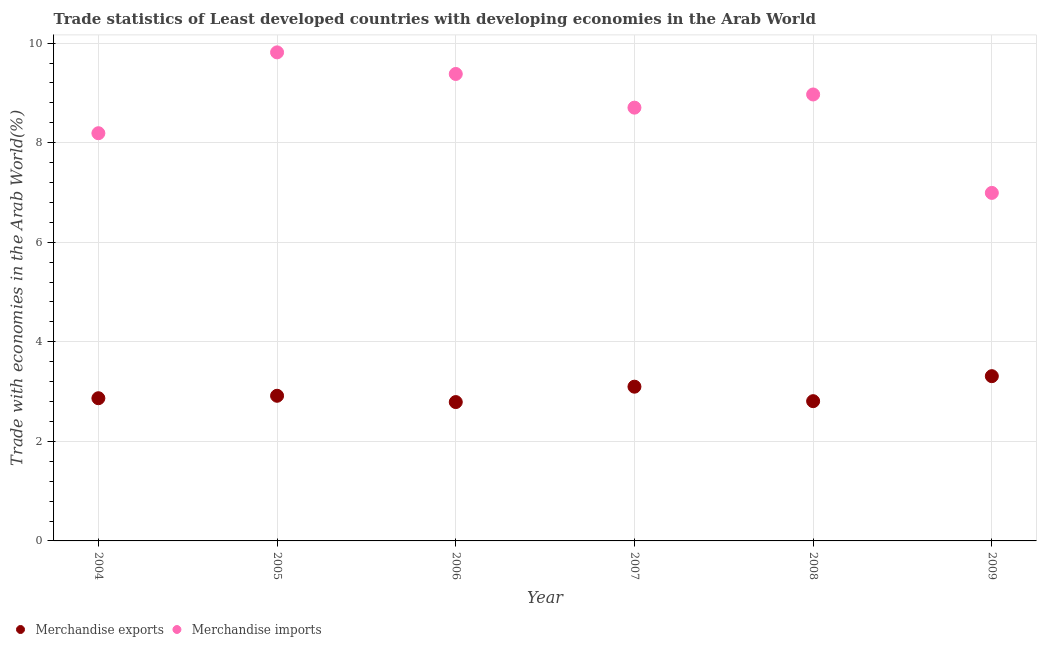How many different coloured dotlines are there?
Provide a succinct answer. 2. Is the number of dotlines equal to the number of legend labels?
Your answer should be very brief. Yes. What is the merchandise imports in 2009?
Make the answer very short. 6.99. Across all years, what is the maximum merchandise exports?
Offer a terse response. 3.31. Across all years, what is the minimum merchandise imports?
Offer a very short reply. 6.99. In which year was the merchandise exports maximum?
Provide a short and direct response. 2009. In which year was the merchandise imports minimum?
Your answer should be compact. 2009. What is the total merchandise imports in the graph?
Your answer should be compact. 52.05. What is the difference between the merchandise exports in 2004 and that in 2008?
Offer a very short reply. 0.06. What is the difference between the merchandise imports in 2005 and the merchandise exports in 2004?
Your response must be concise. 6.95. What is the average merchandise imports per year?
Your answer should be compact. 8.68. In the year 2004, what is the difference between the merchandise imports and merchandise exports?
Provide a succinct answer. 5.32. In how many years, is the merchandise exports greater than 6 %?
Ensure brevity in your answer.  0. What is the ratio of the merchandise imports in 2004 to that in 2006?
Provide a short and direct response. 0.87. Is the difference between the merchandise exports in 2007 and 2009 greater than the difference between the merchandise imports in 2007 and 2009?
Your answer should be very brief. No. What is the difference between the highest and the second highest merchandise exports?
Provide a succinct answer. 0.21. What is the difference between the highest and the lowest merchandise exports?
Provide a short and direct response. 0.52. Is the sum of the merchandise exports in 2007 and 2008 greater than the maximum merchandise imports across all years?
Provide a succinct answer. No. Does the merchandise imports monotonically increase over the years?
Give a very brief answer. No. Is the merchandise exports strictly greater than the merchandise imports over the years?
Your response must be concise. No. Is the merchandise imports strictly less than the merchandise exports over the years?
Your response must be concise. No. How many dotlines are there?
Offer a terse response. 2. Does the graph contain any zero values?
Provide a short and direct response. No. How are the legend labels stacked?
Offer a terse response. Horizontal. What is the title of the graph?
Your response must be concise. Trade statistics of Least developed countries with developing economies in the Arab World. Does "Merchandise imports" appear as one of the legend labels in the graph?
Offer a terse response. Yes. What is the label or title of the Y-axis?
Offer a very short reply. Trade with economies in the Arab World(%). What is the Trade with economies in the Arab World(%) in Merchandise exports in 2004?
Provide a succinct answer. 2.87. What is the Trade with economies in the Arab World(%) in Merchandise imports in 2004?
Ensure brevity in your answer.  8.19. What is the Trade with economies in the Arab World(%) of Merchandise exports in 2005?
Offer a very short reply. 2.92. What is the Trade with economies in the Arab World(%) of Merchandise imports in 2005?
Give a very brief answer. 9.81. What is the Trade with economies in the Arab World(%) in Merchandise exports in 2006?
Provide a short and direct response. 2.79. What is the Trade with economies in the Arab World(%) of Merchandise imports in 2006?
Ensure brevity in your answer.  9.38. What is the Trade with economies in the Arab World(%) of Merchandise exports in 2007?
Offer a very short reply. 3.1. What is the Trade with economies in the Arab World(%) in Merchandise imports in 2007?
Keep it short and to the point. 8.7. What is the Trade with economies in the Arab World(%) in Merchandise exports in 2008?
Offer a terse response. 2.81. What is the Trade with economies in the Arab World(%) in Merchandise imports in 2008?
Ensure brevity in your answer.  8.97. What is the Trade with economies in the Arab World(%) of Merchandise exports in 2009?
Provide a succinct answer. 3.31. What is the Trade with economies in the Arab World(%) in Merchandise imports in 2009?
Keep it short and to the point. 6.99. Across all years, what is the maximum Trade with economies in the Arab World(%) of Merchandise exports?
Give a very brief answer. 3.31. Across all years, what is the maximum Trade with economies in the Arab World(%) in Merchandise imports?
Your response must be concise. 9.81. Across all years, what is the minimum Trade with economies in the Arab World(%) in Merchandise exports?
Make the answer very short. 2.79. Across all years, what is the minimum Trade with economies in the Arab World(%) in Merchandise imports?
Your answer should be compact. 6.99. What is the total Trade with economies in the Arab World(%) of Merchandise exports in the graph?
Keep it short and to the point. 17.79. What is the total Trade with economies in the Arab World(%) in Merchandise imports in the graph?
Offer a very short reply. 52.05. What is the difference between the Trade with economies in the Arab World(%) in Merchandise exports in 2004 and that in 2005?
Your answer should be very brief. -0.05. What is the difference between the Trade with economies in the Arab World(%) in Merchandise imports in 2004 and that in 2005?
Offer a terse response. -1.62. What is the difference between the Trade with economies in the Arab World(%) in Merchandise exports in 2004 and that in 2006?
Your answer should be compact. 0.08. What is the difference between the Trade with economies in the Arab World(%) in Merchandise imports in 2004 and that in 2006?
Give a very brief answer. -1.19. What is the difference between the Trade with economies in the Arab World(%) in Merchandise exports in 2004 and that in 2007?
Make the answer very short. -0.23. What is the difference between the Trade with economies in the Arab World(%) in Merchandise imports in 2004 and that in 2007?
Your response must be concise. -0.51. What is the difference between the Trade with economies in the Arab World(%) of Merchandise exports in 2004 and that in 2008?
Offer a terse response. 0.06. What is the difference between the Trade with economies in the Arab World(%) in Merchandise imports in 2004 and that in 2008?
Make the answer very short. -0.78. What is the difference between the Trade with economies in the Arab World(%) in Merchandise exports in 2004 and that in 2009?
Your answer should be very brief. -0.44. What is the difference between the Trade with economies in the Arab World(%) in Merchandise imports in 2004 and that in 2009?
Offer a very short reply. 1.2. What is the difference between the Trade with economies in the Arab World(%) of Merchandise exports in 2005 and that in 2006?
Your answer should be compact. 0.13. What is the difference between the Trade with economies in the Arab World(%) in Merchandise imports in 2005 and that in 2006?
Provide a succinct answer. 0.43. What is the difference between the Trade with economies in the Arab World(%) in Merchandise exports in 2005 and that in 2007?
Provide a short and direct response. -0.18. What is the difference between the Trade with economies in the Arab World(%) of Merchandise imports in 2005 and that in 2007?
Offer a very short reply. 1.11. What is the difference between the Trade with economies in the Arab World(%) in Merchandise exports in 2005 and that in 2008?
Your answer should be compact. 0.11. What is the difference between the Trade with economies in the Arab World(%) in Merchandise imports in 2005 and that in 2008?
Your answer should be compact. 0.85. What is the difference between the Trade with economies in the Arab World(%) of Merchandise exports in 2005 and that in 2009?
Ensure brevity in your answer.  -0.39. What is the difference between the Trade with economies in the Arab World(%) of Merchandise imports in 2005 and that in 2009?
Keep it short and to the point. 2.82. What is the difference between the Trade with economies in the Arab World(%) in Merchandise exports in 2006 and that in 2007?
Ensure brevity in your answer.  -0.31. What is the difference between the Trade with economies in the Arab World(%) in Merchandise imports in 2006 and that in 2007?
Your response must be concise. 0.68. What is the difference between the Trade with economies in the Arab World(%) in Merchandise exports in 2006 and that in 2008?
Offer a terse response. -0.02. What is the difference between the Trade with economies in the Arab World(%) of Merchandise imports in 2006 and that in 2008?
Your answer should be very brief. 0.41. What is the difference between the Trade with economies in the Arab World(%) of Merchandise exports in 2006 and that in 2009?
Provide a short and direct response. -0.52. What is the difference between the Trade with economies in the Arab World(%) of Merchandise imports in 2006 and that in 2009?
Your answer should be compact. 2.39. What is the difference between the Trade with economies in the Arab World(%) of Merchandise exports in 2007 and that in 2008?
Your response must be concise. 0.29. What is the difference between the Trade with economies in the Arab World(%) in Merchandise imports in 2007 and that in 2008?
Offer a very short reply. -0.26. What is the difference between the Trade with economies in the Arab World(%) of Merchandise exports in 2007 and that in 2009?
Your answer should be compact. -0.21. What is the difference between the Trade with economies in the Arab World(%) of Merchandise imports in 2007 and that in 2009?
Offer a terse response. 1.71. What is the difference between the Trade with economies in the Arab World(%) of Merchandise exports in 2008 and that in 2009?
Ensure brevity in your answer.  -0.5. What is the difference between the Trade with economies in the Arab World(%) of Merchandise imports in 2008 and that in 2009?
Your response must be concise. 1.98. What is the difference between the Trade with economies in the Arab World(%) in Merchandise exports in 2004 and the Trade with economies in the Arab World(%) in Merchandise imports in 2005?
Ensure brevity in your answer.  -6.95. What is the difference between the Trade with economies in the Arab World(%) in Merchandise exports in 2004 and the Trade with economies in the Arab World(%) in Merchandise imports in 2006?
Your answer should be very brief. -6.51. What is the difference between the Trade with economies in the Arab World(%) in Merchandise exports in 2004 and the Trade with economies in the Arab World(%) in Merchandise imports in 2007?
Your answer should be compact. -5.84. What is the difference between the Trade with economies in the Arab World(%) of Merchandise exports in 2004 and the Trade with economies in the Arab World(%) of Merchandise imports in 2008?
Offer a very short reply. -6.1. What is the difference between the Trade with economies in the Arab World(%) of Merchandise exports in 2004 and the Trade with economies in the Arab World(%) of Merchandise imports in 2009?
Make the answer very short. -4.12. What is the difference between the Trade with economies in the Arab World(%) in Merchandise exports in 2005 and the Trade with economies in the Arab World(%) in Merchandise imports in 2006?
Provide a short and direct response. -6.46. What is the difference between the Trade with economies in the Arab World(%) of Merchandise exports in 2005 and the Trade with economies in the Arab World(%) of Merchandise imports in 2007?
Your answer should be very brief. -5.79. What is the difference between the Trade with economies in the Arab World(%) in Merchandise exports in 2005 and the Trade with economies in the Arab World(%) in Merchandise imports in 2008?
Make the answer very short. -6.05. What is the difference between the Trade with economies in the Arab World(%) of Merchandise exports in 2005 and the Trade with economies in the Arab World(%) of Merchandise imports in 2009?
Make the answer very short. -4.08. What is the difference between the Trade with economies in the Arab World(%) in Merchandise exports in 2006 and the Trade with economies in the Arab World(%) in Merchandise imports in 2007?
Provide a short and direct response. -5.91. What is the difference between the Trade with economies in the Arab World(%) in Merchandise exports in 2006 and the Trade with economies in the Arab World(%) in Merchandise imports in 2008?
Offer a terse response. -6.18. What is the difference between the Trade with economies in the Arab World(%) of Merchandise exports in 2006 and the Trade with economies in the Arab World(%) of Merchandise imports in 2009?
Offer a terse response. -4.2. What is the difference between the Trade with economies in the Arab World(%) of Merchandise exports in 2007 and the Trade with economies in the Arab World(%) of Merchandise imports in 2008?
Your answer should be compact. -5.87. What is the difference between the Trade with economies in the Arab World(%) in Merchandise exports in 2007 and the Trade with economies in the Arab World(%) in Merchandise imports in 2009?
Give a very brief answer. -3.89. What is the difference between the Trade with economies in the Arab World(%) in Merchandise exports in 2008 and the Trade with economies in the Arab World(%) in Merchandise imports in 2009?
Ensure brevity in your answer.  -4.18. What is the average Trade with economies in the Arab World(%) in Merchandise exports per year?
Give a very brief answer. 2.96. What is the average Trade with economies in the Arab World(%) in Merchandise imports per year?
Make the answer very short. 8.68. In the year 2004, what is the difference between the Trade with economies in the Arab World(%) of Merchandise exports and Trade with economies in the Arab World(%) of Merchandise imports?
Ensure brevity in your answer.  -5.32. In the year 2005, what is the difference between the Trade with economies in the Arab World(%) of Merchandise exports and Trade with economies in the Arab World(%) of Merchandise imports?
Keep it short and to the point. -6.9. In the year 2006, what is the difference between the Trade with economies in the Arab World(%) in Merchandise exports and Trade with economies in the Arab World(%) in Merchandise imports?
Keep it short and to the point. -6.59. In the year 2007, what is the difference between the Trade with economies in the Arab World(%) of Merchandise exports and Trade with economies in the Arab World(%) of Merchandise imports?
Offer a terse response. -5.61. In the year 2008, what is the difference between the Trade with economies in the Arab World(%) in Merchandise exports and Trade with economies in the Arab World(%) in Merchandise imports?
Make the answer very short. -6.16. In the year 2009, what is the difference between the Trade with economies in the Arab World(%) of Merchandise exports and Trade with economies in the Arab World(%) of Merchandise imports?
Ensure brevity in your answer.  -3.68. What is the ratio of the Trade with economies in the Arab World(%) in Merchandise exports in 2004 to that in 2005?
Provide a succinct answer. 0.98. What is the ratio of the Trade with economies in the Arab World(%) in Merchandise imports in 2004 to that in 2005?
Give a very brief answer. 0.83. What is the ratio of the Trade with economies in the Arab World(%) in Merchandise exports in 2004 to that in 2006?
Your answer should be very brief. 1.03. What is the ratio of the Trade with economies in the Arab World(%) of Merchandise imports in 2004 to that in 2006?
Provide a short and direct response. 0.87. What is the ratio of the Trade with economies in the Arab World(%) of Merchandise exports in 2004 to that in 2007?
Provide a short and direct response. 0.93. What is the ratio of the Trade with economies in the Arab World(%) of Merchandise imports in 2004 to that in 2007?
Your response must be concise. 0.94. What is the ratio of the Trade with economies in the Arab World(%) in Merchandise exports in 2004 to that in 2008?
Provide a short and direct response. 1.02. What is the ratio of the Trade with economies in the Arab World(%) of Merchandise imports in 2004 to that in 2008?
Offer a very short reply. 0.91. What is the ratio of the Trade with economies in the Arab World(%) in Merchandise exports in 2004 to that in 2009?
Your answer should be very brief. 0.87. What is the ratio of the Trade with economies in the Arab World(%) of Merchandise imports in 2004 to that in 2009?
Keep it short and to the point. 1.17. What is the ratio of the Trade with economies in the Arab World(%) of Merchandise exports in 2005 to that in 2006?
Keep it short and to the point. 1.05. What is the ratio of the Trade with economies in the Arab World(%) in Merchandise imports in 2005 to that in 2006?
Provide a short and direct response. 1.05. What is the ratio of the Trade with economies in the Arab World(%) in Merchandise exports in 2005 to that in 2007?
Your answer should be very brief. 0.94. What is the ratio of the Trade with economies in the Arab World(%) in Merchandise imports in 2005 to that in 2007?
Make the answer very short. 1.13. What is the ratio of the Trade with economies in the Arab World(%) in Merchandise exports in 2005 to that in 2008?
Your answer should be very brief. 1.04. What is the ratio of the Trade with economies in the Arab World(%) of Merchandise imports in 2005 to that in 2008?
Offer a very short reply. 1.09. What is the ratio of the Trade with economies in the Arab World(%) of Merchandise exports in 2005 to that in 2009?
Offer a terse response. 0.88. What is the ratio of the Trade with economies in the Arab World(%) of Merchandise imports in 2005 to that in 2009?
Keep it short and to the point. 1.4. What is the ratio of the Trade with economies in the Arab World(%) in Merchandise exports in 2006 to that in 2007?
Provide a succinct answer. 0.9. What is the ratio of the Trade with economies in the Arab World(%) of Merchandise imports in 2006 to that in 2007?
Give a very brief answer. 1.08. What is the ratio of the Trade with economies in the Arab World(%) in Merchandise exports in 2006 to that in 2008?
Make the answer very short. 0.99. What is the ratio of the Trade with economies in the Arab World(%) of Merchandise imports in 2006 to that in 2008?
Provide a short and direct response. 1.05. What is the ratio of the Trade with economies in the Arab World(%) in Merchandise exports in 2006 to that in 2009?
Provide a succinct answer. 0.84. What is the ratio of the Trade with economies in the Arab World(%) in Merchandise imports in 2006 to that in 2009?
Offer a terse response. 1.34. What is the ratio of the Trade with economies in the Arab World(%) of Merchandise exports in 2007 to that in 2008?
Your response must be concise. 1.1. What is the ratio of the Trade with economies in the Arab World(%) in Merchandise imports in 2007 to that in 2008?
Your response must be concise. 0.97. What is the ratio of the Trade with economies in the Arab World(%) of Merchandise exports in 2007 to that in 2009?
Offer a very short reply. 0.94. What is the ratio of the Trade with economies in the Arab World(%) of Merchandise imports in 2007 to that in 2009?
Your answer should be very brief. 1.25. What is the ratio of the Trade with economies in the Arab World(%) of Merchandise exports in 2008 to that in 2009?
Offer a terse response. 0.85. What is the ratio of the Trade with economies in the Arab World(%) in Merchandise imports in 2008 to that in 2009?
Give a very brief answer. 1.28. What is the difference between the highest and the second highest Trade with economies in the Arab World(%) of Merchandise exports?
Your response must be concise. 0.21. What is the difference between the highest and the second highest Trade with economies in the Arab World(%) in Merchandise imports?
Ensure brevity in your answer.  0.43. What is the difference between the highest and the lowest Trade with economies in the Arab World(%) in Merchandise exports?
Provide a succinct answer. 0.52. What is the difference between the highest and the lowest Trade with economies in the Arab World(%) of Merchandise imports?
Provide a succinct answer. 2.82. 